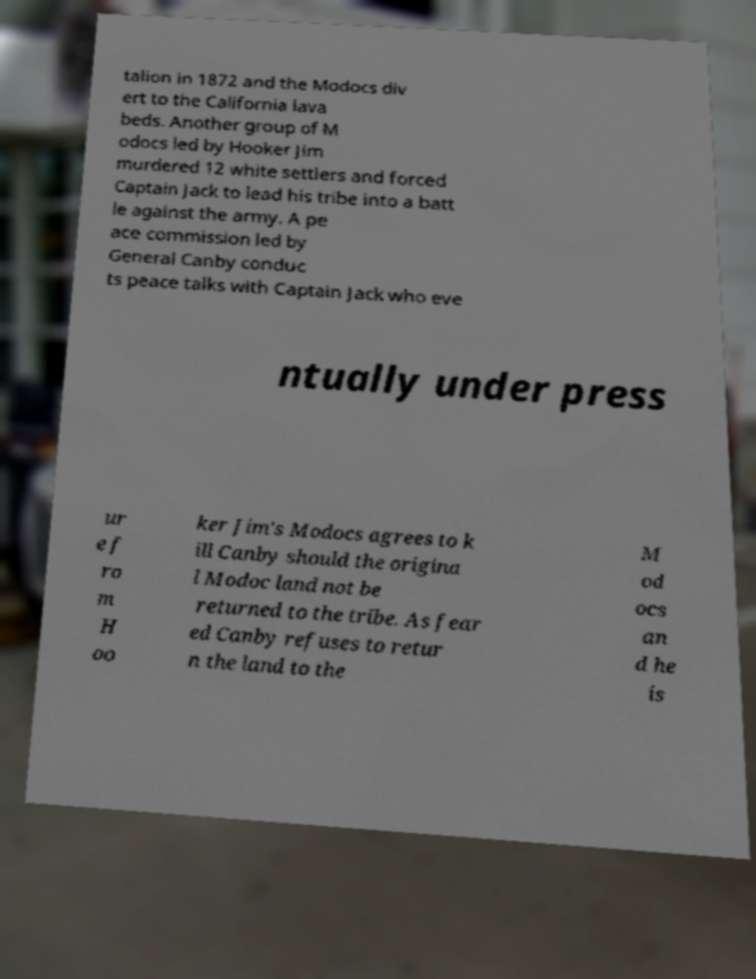Can you read and provide the text displayed in the image?This photo seems to have some interesting text. Can you extract and type it out for me? talion in 1872 and the Modocs div ert to the California lava beds. Another group of M odocs led by Hooker Jim murdered 12 white settlers and forced Captain Jack to lead his tribe into a batt le against the army. A pe ace commission led by General Canby conduc ts peace talks with Captain Jack who eve ntually under press ur e f ro m H oo ker Jim's Modocs agrees to k ill Canby should the origina l Modoc land not be returned to the tribe. As fear ed Canby refuses to retur n the land to the M od ocs an d he is 